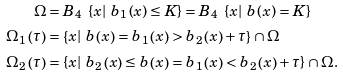<formula> <loc_0><loc_0><loc_500><loc_500>\Omega & = B _ { 4 } \ \left \{ x | \ b _ { 1 } \left ( x \right ) \leq K \right \} = B _ { 4 } \ \left \{ x | \ b \left ( x \right ) = K \right \} \\ \Omega _ { 1 } \left ( \tau \right ) & = \left \{ x | \ b \left ( x \right ) = b _ { 1 } \left ( x \right ) > b _ { 2 } \left ( x \right ) + \tau \right \} \cap \Omega \\ \Omega _ { 2 } \left ( \tau \right ) & = \left \{ x | \ b _ { 2 } \left ( x \right ) \leq b \left ( x \right ) = b _ { 1 } \left ( x \right ) < b _ { 2 } \left ( x \right ) + \tau \right \} \cap \Omega .</formula> 